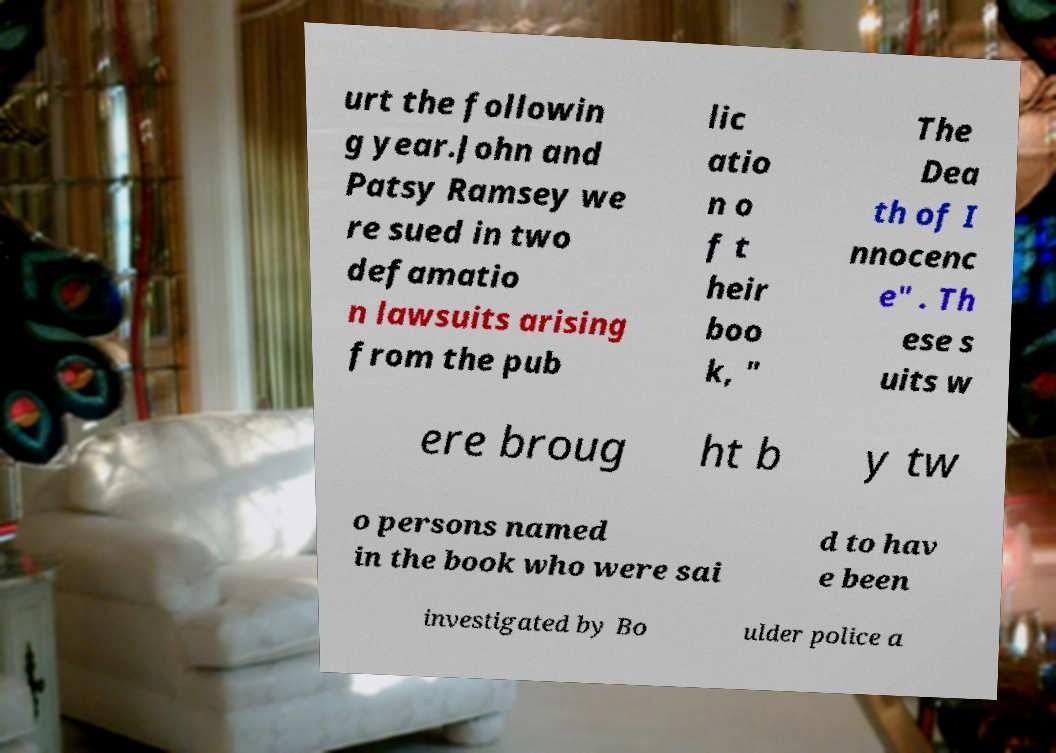Could you extract and type out the text from this image? urt the followin g year.John and Patsy Ramsey we re sued in two defamatio n lawsuits arising from the pub lic atio n o f t heir boo k, " The Dea th of I nnocenc e" . Th ese s uits w ere broug ht b y tw o persons named in the book who were sai d to hav e been investigated by Bo ulder police a 